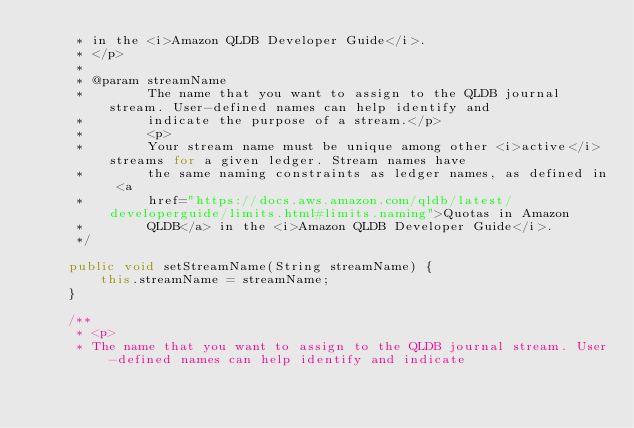<code> <loc_0><loc_0><loc_500><loc_500><_Java_>     * in the <i>Amazon QLDB Developer Guide</i>.
     * </p>
     * 
     * @param streamName
     *        The name that you want to assign to the QLDB journal stream. User-defined names can help identify and
     *        indicate the purpose of a stream.</p>
     *        <p>
     *        Your stream name must be unique among other <i>active</i> streams for a given ledger. Stream names have
     *        the same naming constraints as ledger names, as defined in <a
     *        href="https://docs.aws.amazon.com/qldb/latest/developerguide/limits.html#limits.naming">Quotas in Amazon
     *        QLDB</a> in the <i>Amazon QLDB Developer Guide</i>.
     */

    public void setStreamName(String streamName) {
        this.streamName = streamName;
    }

    /**
     * <p>
     * The name that you want to assign to the QLDB journal stream. User-defined names can help identify and indicate</code> 